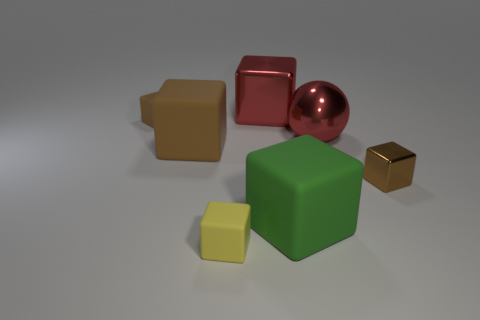Subtract all green rubber blocks. How many blocks are left? 5 Add 2 blue cylinders. How many objects exist? 9 Subtract all gray balls. How many brown blocks are left? 3 Subtract 3 blocks. How many blocks are left? 3 Subtract all yellow cubes. How many cubes are left? 5 Subtract all balls. How many objects are left? 6 Subtract all blue spheres. Subtract all green cylinders. How many spheres are left? 1 Subtract all small purple rubber spheres. Subtract all balls. How many objects are left? 6 Add 2 tiny matte objects. How many tiny matte objects are left? 4 Add 2 tiny blue metal cylinders. How many tiny blue metal cylinders exist? 2 